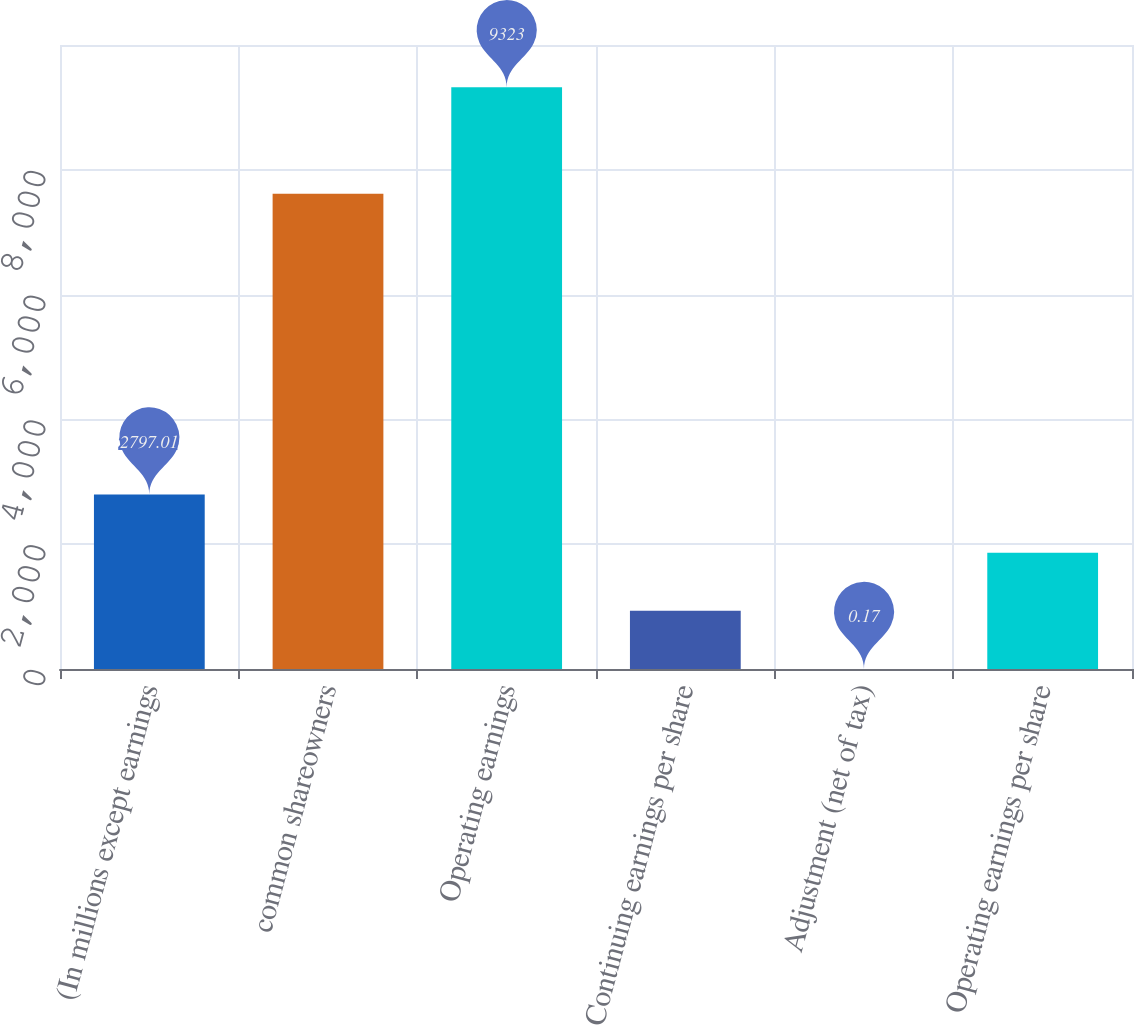<chart> <loc_0><loc_0><loc_500><loc_500><bar_chart><fcel>(In millions except earnings<fcel>common shareowners<fcel>Operating earnings<fcel>Continuing earnings per share<fcel>Adjustment (net of tax)<fcel>Operating earnings per share<nl><fcel>2797.01<fcel>7618<fcel>9323<fcel>932.45<fcel>0.17<fcel>1864.73<nl></chart> 